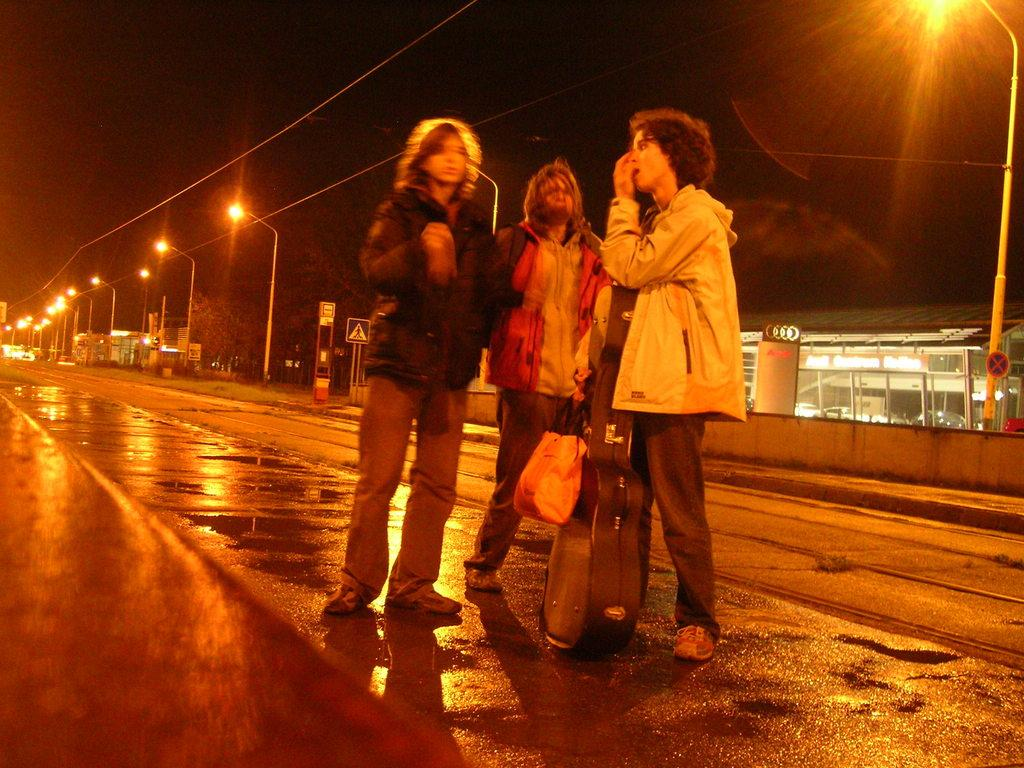What can be observed about the people in the image? There are people standing in the image. What items are visible that the people might be carrying? Bags are visible in the image. What structures are present in the image that might be used for support or signage? Poles are present in the image. What type of surface can be seen in the image that people might walk or drive on? There is a road in the image. What objects are visible in the image that might provide illumination? Lights are visible in the image. What objects are present in the image that might be used for displaying information or advertisements? Boards are present in the image. What type of shelter or storage space can be seen in the image? There is a shed in the image. What objects are visible in the image that might be used for transmitting electricity or data? Wires are visible in the image. What type of natural elements are present in the image? Trees are present in the image. How would you describe the overall lighting conditions in the image? The background of the image is dark. What is the condition of the detail on the recess in the image? There is no recess present in the image, so it is not possible to determine the condition of any detail on it. 